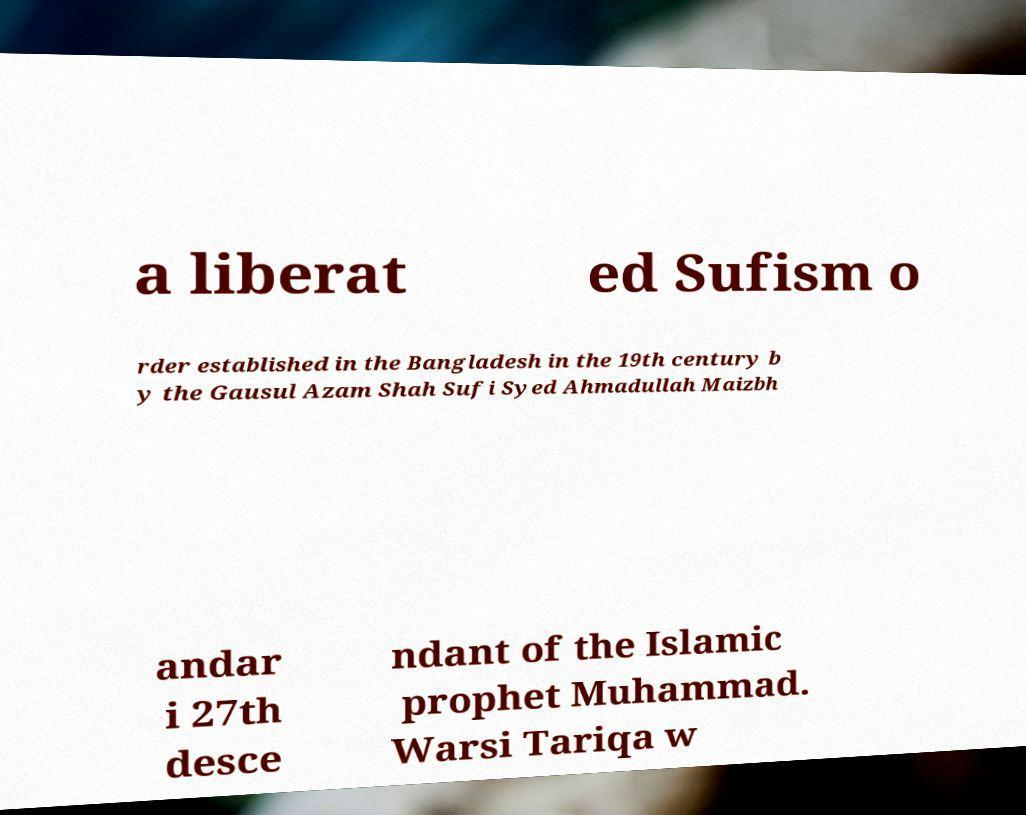Could you extract and type out the text from this image? a liberat ed Sufism o rder established in the Bangladesh in the 19th century b y the Gausul Azam Shah Sufi Syed Ahmadullah Maizbh andar i 27th desce ndant of the Islamic prophet Muhammad. Warsi Tariqa w 